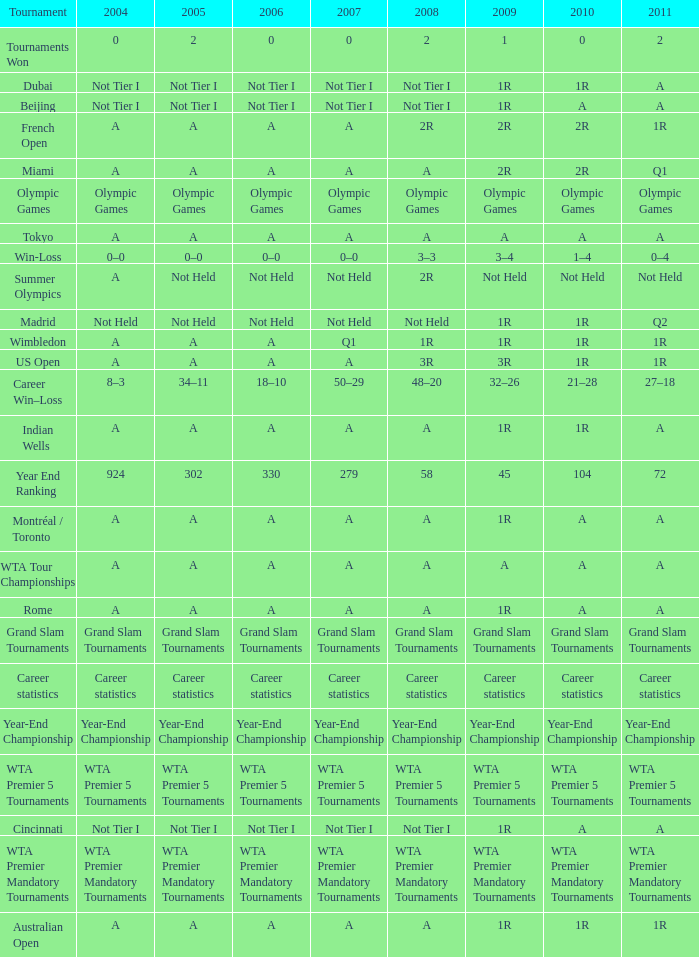What is 2007, when Tournament is "Madrid"? Not Held. 